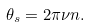Convert formula to latex. <formula><loc_0><loc_0><loc_500><loc_500>\theta _ { s } = 2 \pi \nu n .</formula> 